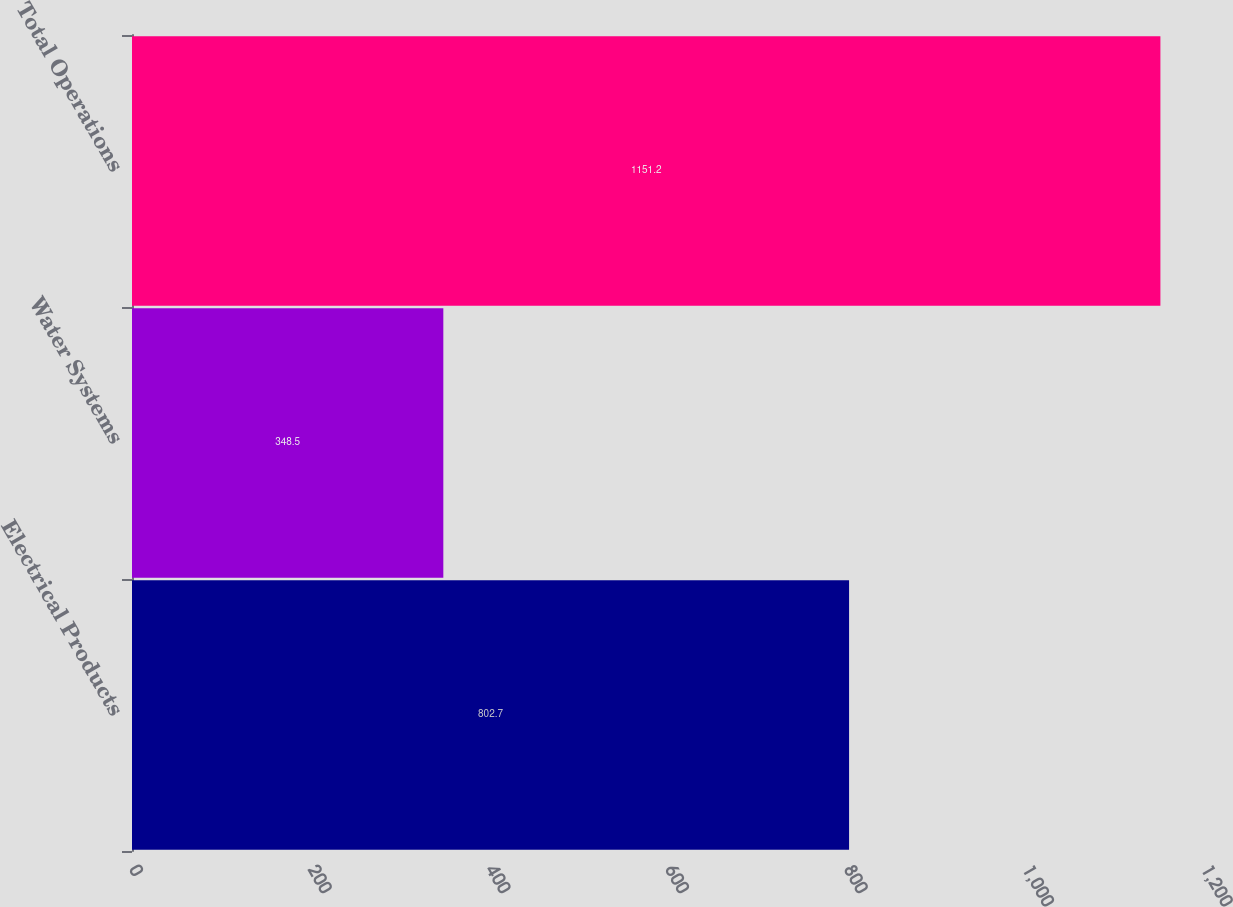Convert chart to OTSL. <chart><loc_0><loc_0><loc_500><loc_500><bar_chart><fcel>Electrical Products<fcel>Water Systems<fcel>Total Operations<nl><fcel>802.7<fcel>348.5<fcel>1151.2<nl></chart> 